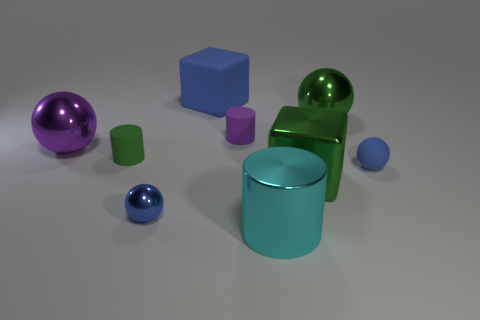What number of other objects are there of the same color as the big cylinder?
Your answer should be very brief. 0. Is the shape of the big green thing that is in front of the small green cylinder the same as the blue rubber thing that is to the left of the big green cube?
Your answer should be compact. Yes. What is the material of the big sphere right of the large blue matte cube?
Keep it short and to the point. Metal. The cube that is the same color as the small matte ball is what size?
Your answer should be very brief. Large. How many things are large green blocks that are in front of the purple matte cylinder or purple objects?
Keep it short and to the point. 3. Are there an equal number of rubber spheres left of the purple matte cylinder and brown objects?
Offer a terse response. Yes. Is the blue shiny ball the same size as the matte sphere?
Offer a terse response. Yes. What is the color of the matte block that is the same size as the purple shiny object?
Offer a very short reply. Blue. Does the cyan metal cylinder have the same size as the green metal block in front of the blue block?
Your answer should be compact. Yes. How many balls have the same color as the large matte cube?
Give a very brief answer. 2. 